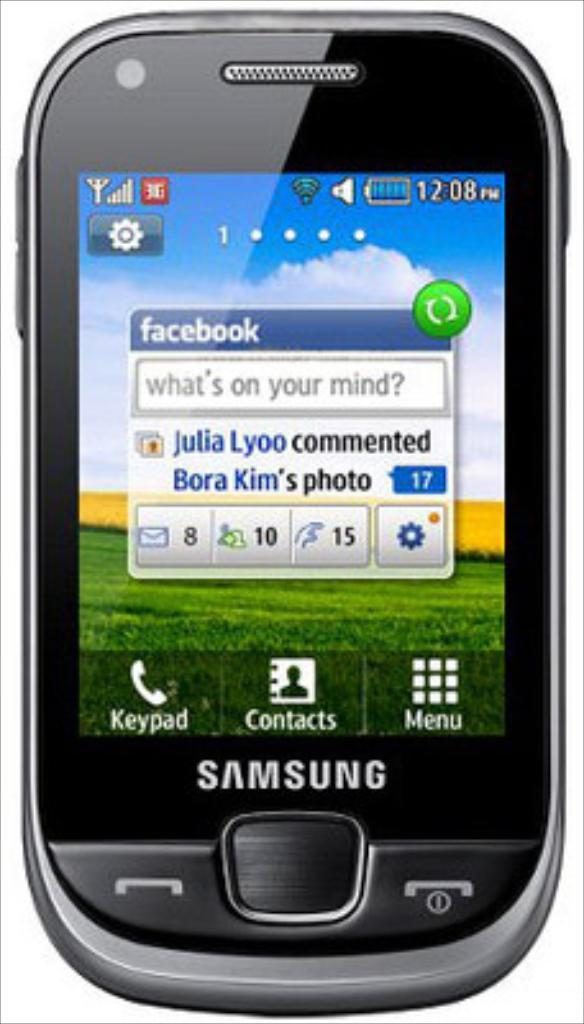<image>
Create a compact narrative representing the image presented. A black Samsung brand cellphone with a facebook messenger app displayed on the screen 